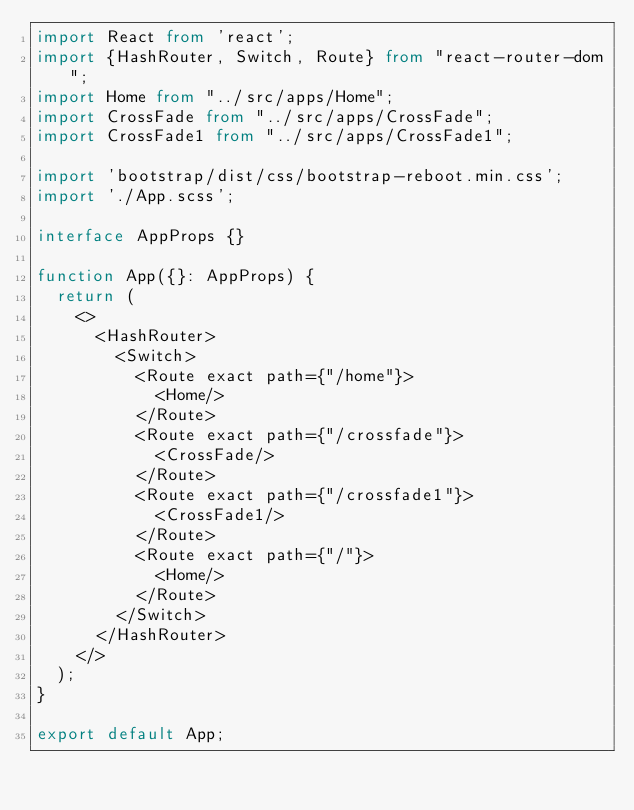<code> <loc_0><loc_0><loc_500><loc_500><_TypeScript_>import React from 'react';
import {HashRouter, Switch, Route} from "react-router-dom";
import Home from "../src/apps/Home";
import CrossFade from "../src/apps/CrossFade";
import CrossFade1 from "../src/apps/CrossFade1";

import 'bootstrap/dist/css/bootstrap-reboot.min.css';
import './App.scss';

interface AppProps {}

function App({}: AppProps) {
  return (
    <>
      <HashRouter>
        <Switch>
          <Route exact path={"/home"}>
            <Home/>
          </Route>
          <Route exact path={"/crossfade"}>
            <CrossFade/>
          </Route>
          <Route exact path={"/crossfade1"}>
            <CrossFade1/>
          </Route>
          <Route exact path={"/"}>
            <Home/>
          </Route>
        </Switch>
      </HashRouter>
    </>
  );
}

export default App;
</code> 